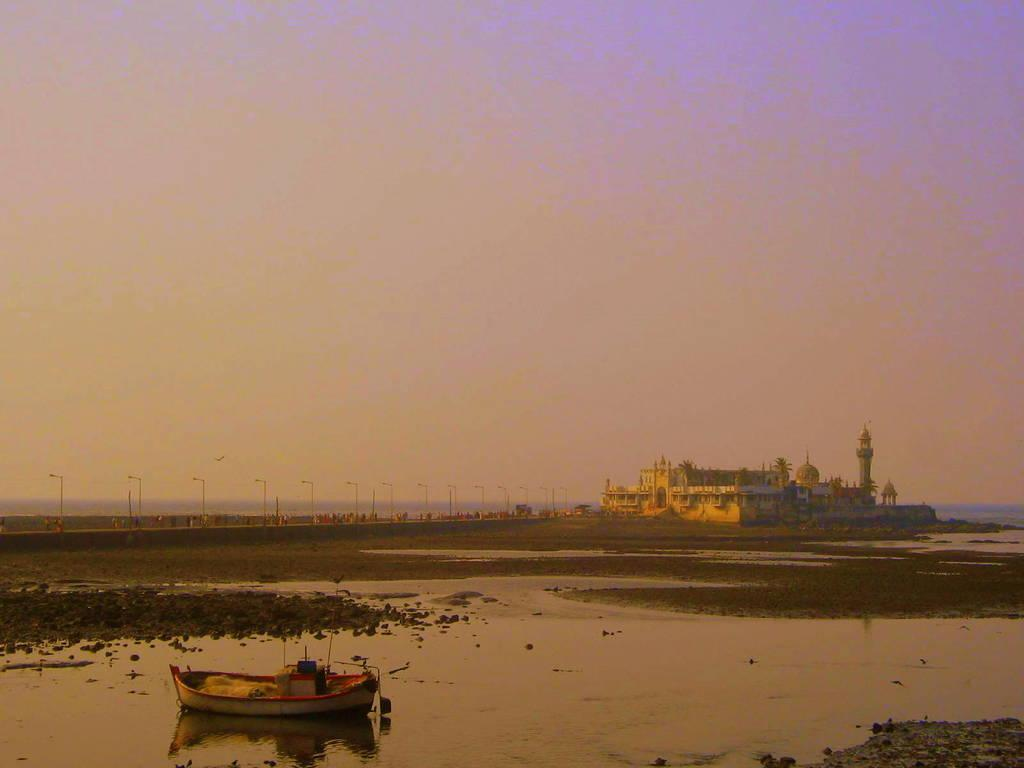What is the main subject of the image? The main subject of the image is a boat. What type of environment is depicted in the image? The image shows a boat on water, with ground, poles, lights, a building, and the sky visible. Can you describe the setting of the image? The setting includes water, ground, poles, lights, a building, and the sky. What is the color of the sky in the image? The sky is visible in the image, but the color is not mentioned in the provided facts. Are there any fairies flying around the boat in the image? There is no mention of fairies in the provided facts, so we cannot determine if they are present in the image. What type of pot is used to catch the falling leaves in the image? There is no mention of leaves or a pot in the provided facts, so we cannot determine if they are present in the image. 